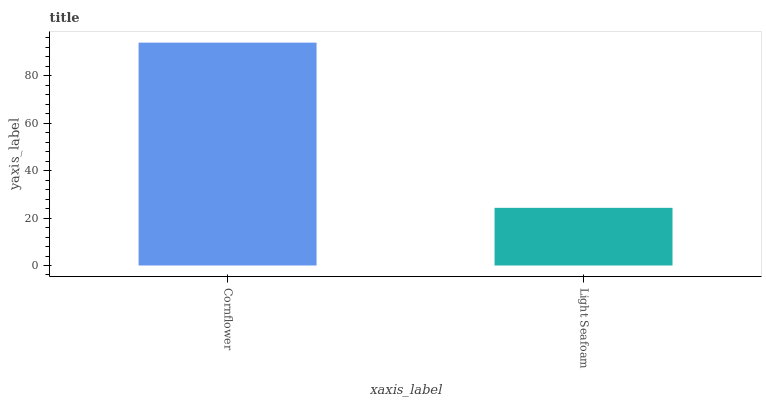Is Light Seafoam the minimum?
Answer yes or no. Yes. Is Cornflower the maximum?
Answer yes or no. Yes. Is Light Seafoam the maximum?
Answer yes or no. No. Is Cornflower greater than Light Seafoam?
Answer yes or no. Yes. Is Light Seafoam less than Cornflower?
Answer yes or no. Yes. Is Light Seafoam greater than Cornflower?
Answer yes or no. No. Is Cornflower less than Light Seafoam?
Answer yes or no. No. Is Cornflower the high median?
Answer yes or no. Yes. Is Light Seafoam the low median?
Answer yes or no. Yes. Is Light Seafoam the high median?
Answer yes or no. No. Is Cornflower the low median?
Answer yes or no. No. 